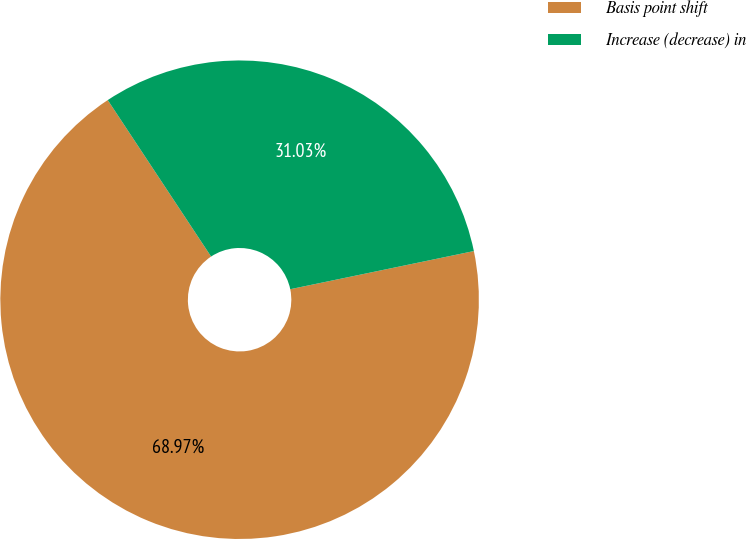Convert chart to OTSL. <chart><loc_0><loc_0><loc_500><loc_500><pie_chart><fcel>Basis point shift<fcel>Increase (decrease) in<nl><fcel>68.97%<fcel>31.03%<nl></chart> 